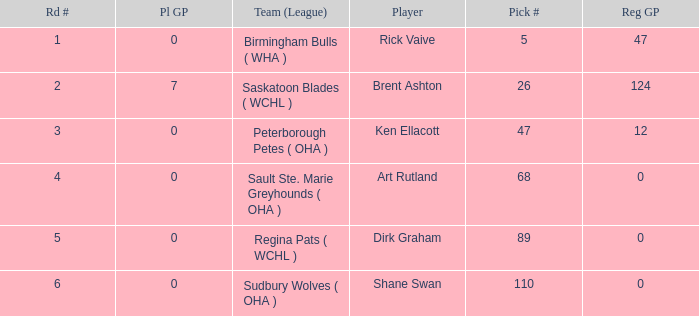How many rounds exist for picks under 5? 0.0. 